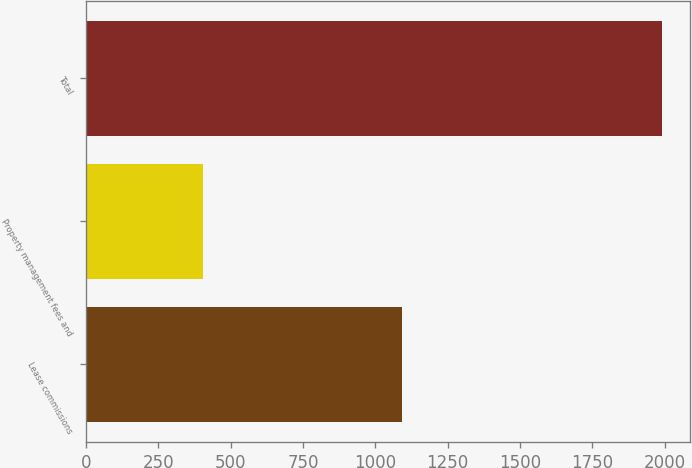<chart> <loc_0><loc_0><loc_500><loc_500><bar_chart><fcel>Lease commissions<fcel>Property management fees and<fcel>Total<nl><fcel>1092<fcel>406<fcel>1989<nl></chart> 